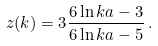<formula> <loc_0><loc_0><loc_500><loc_500>z ( k ) = 3 \frac { 6 \ln k a - 3 } { 6 \ln k a - 5 } \, .</formula> 